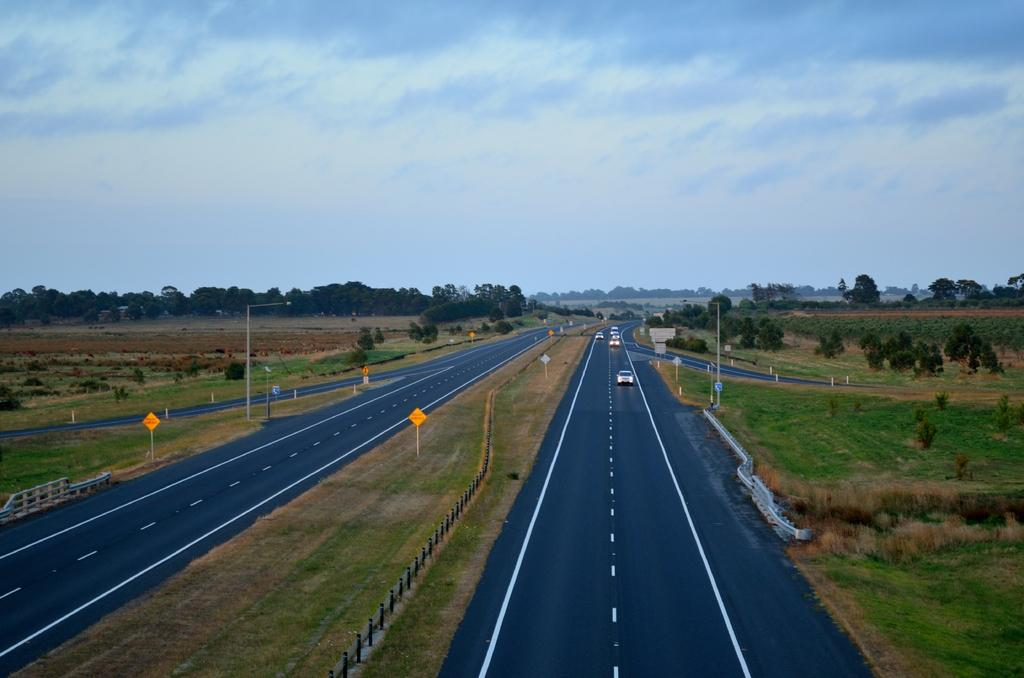What can be seen on the road in the image? There are vehicles on the road in the image. What structures are present in the image? There are poles, lights, and boards in the image. What type of vegetation is visible in the image? There are plants and trees in the image. What is visible in the background of the image? The sky is visible in the background of the image. Can you see a line of snakes crossing the road in the image? There are no snakes present in the image, and therefore no such line can be observed. What type of net is used to catch the lights in the image? There is no net present in the image; the lights are attached to poles or boards. 